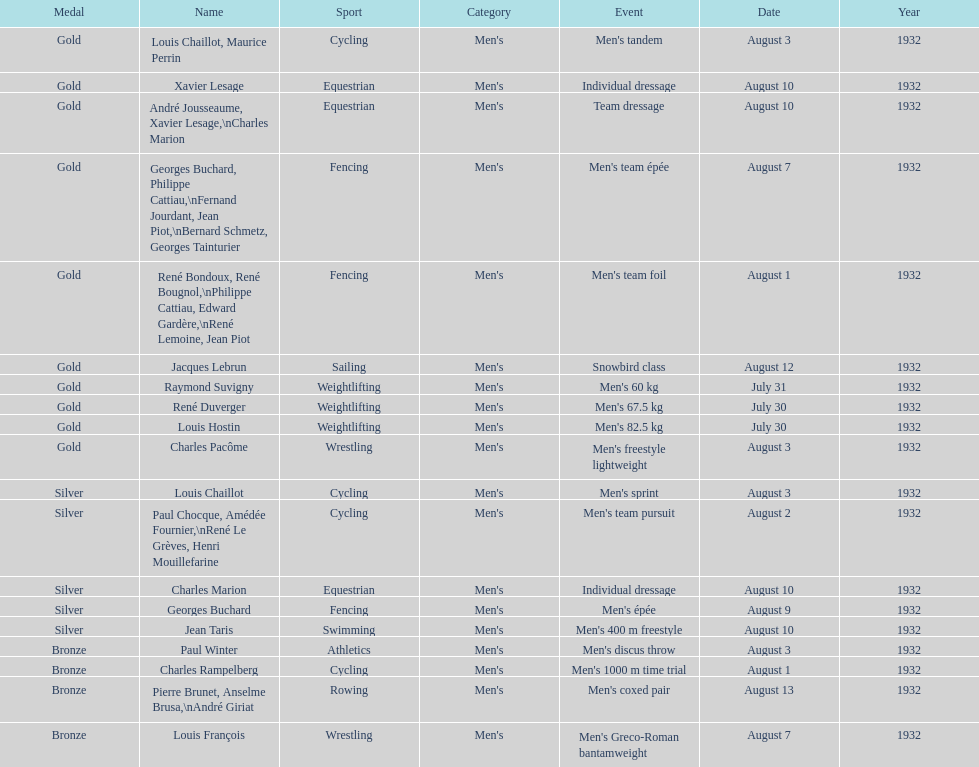What sport is listed first? Cycling. 